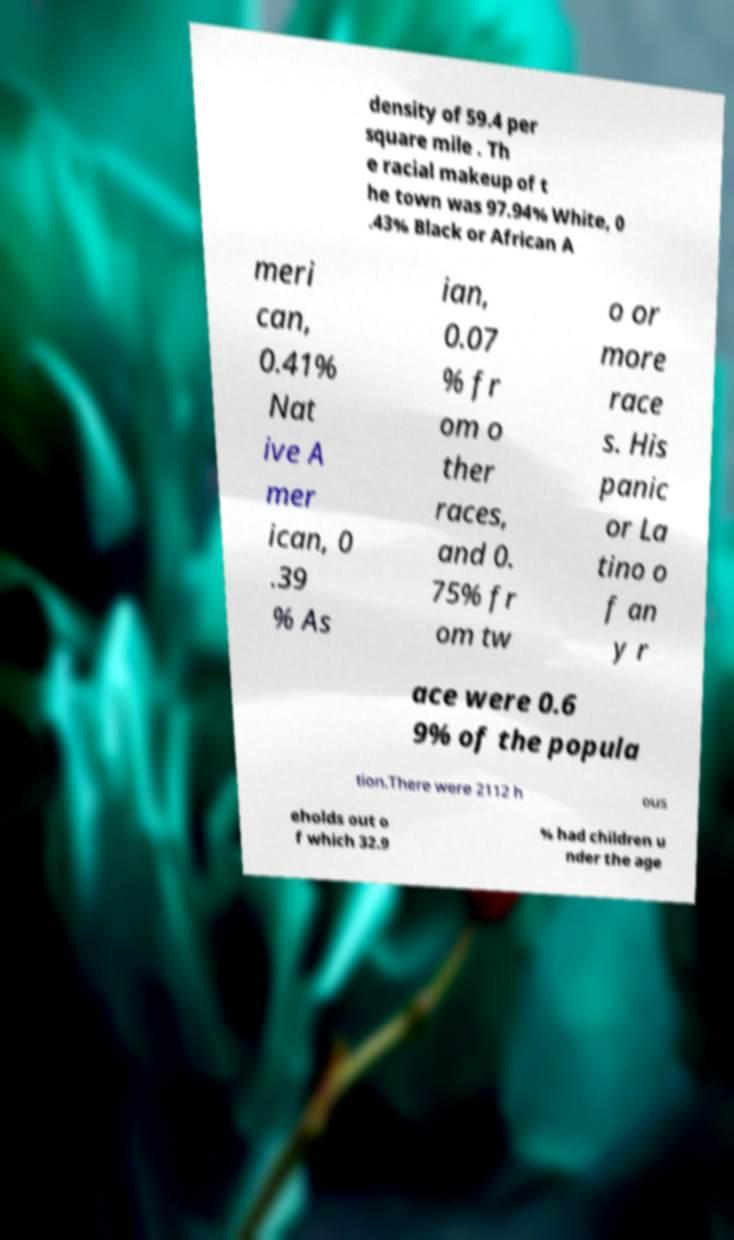Please read and relay the text visible in this image. What does it say? density of 59.4 per square mile . Th e racial makeup of t he town was 97.94% White, 0 .43% Black or African A meri can, 0.41% Nat ive A mer ican, 0 .39 % As ian, 0.07 % fr om o ther races, and 0. 75% fr om tw o or more race s. His panic or La tino o f an y r ace were 0.6 9% of the popula tion.There were 2112 h ous eholds out o f which 32.9 % had children u nder the age 